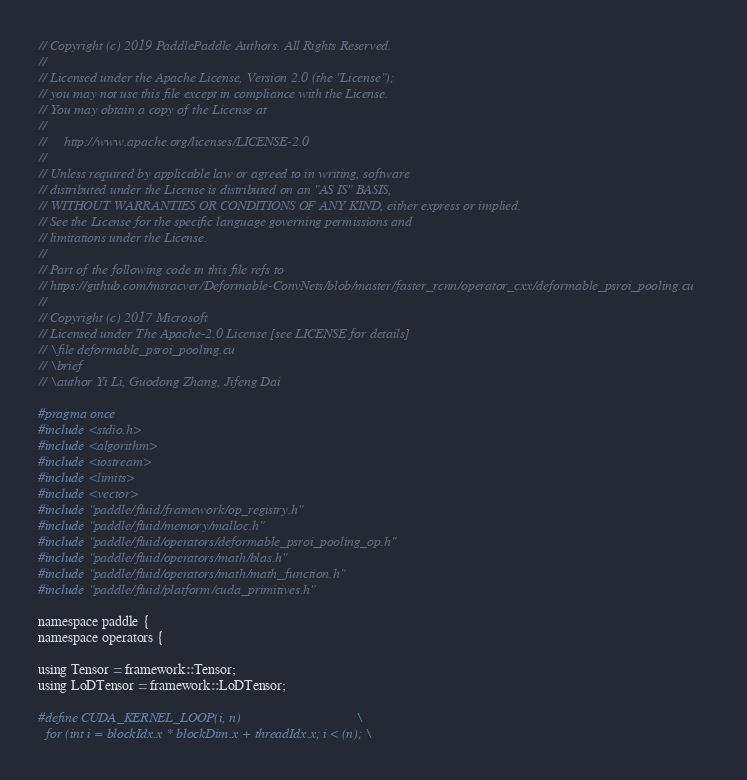Convert code to text. <code><loc_0><loc_0><loc_500><loc_500><_Cuda_>// Copyright (c) 2019 PaddlePaddle Authors. All Rights Reserved.
//
// Licensed under the Apache License, Version 2.0 (the "License");
// you may not use this file except in compliance with the License.
// You may obtain a copy of the License at
//
//     http://www.apache.org/licenses/LICENSE-2.0
//
// Unless required by applicable law or agreed to in writing, software
// distributed under the License is distributed on an "AS IS" BASIS,
// WITHOUT WARRANTIES OR CONDITIONS OF ANY KIND, either express or implied.
// See the License for the specific language governing permissions and
// limitations under the License.
//
// Part of the following code in this file refs to
// https://github.com/msracver/Deformable-ConvNets/blob/master/faster_rcnn/operator_cxx/deformable_psroi_pooling.cu
//
// Copyright (c) 2017 Microsoft
// Licensed under The Apache-2.0 License [see LICENSE for details]
// \file deformable_psroi_pooling.cu
// \brief
// \author Yi Li, Guodong Zhang, Jifeng Dai

#pragma once
#include <stdio.h>
#include <algorithm>
#include <iostream>
#include <limits>
#include <vector>
#include "paddle/fluid/framework/op_registry.h"
#include "paddle/fluid/memory/malloc.h"
#include "paddle/fluid/operators/deformable_psroi_pooling_op.h"
#include "paddle/fluid/operators/math/blas.h"
#include "paddle/fluid/operators/math/math_function.h"
#include "paddle/fluid/platform/cuda_primitives.h"

namespace paddle {
namespace operators {

using Tensor = framework::Tensor;
using LoDTensor = framework::LoDTensor;

#define CUDA_KERNEL_LOOP(i, n)                                 \
  for (int i = blockIdx.x * blockDim.x + threadIdx.x; i < (n); \</code> 